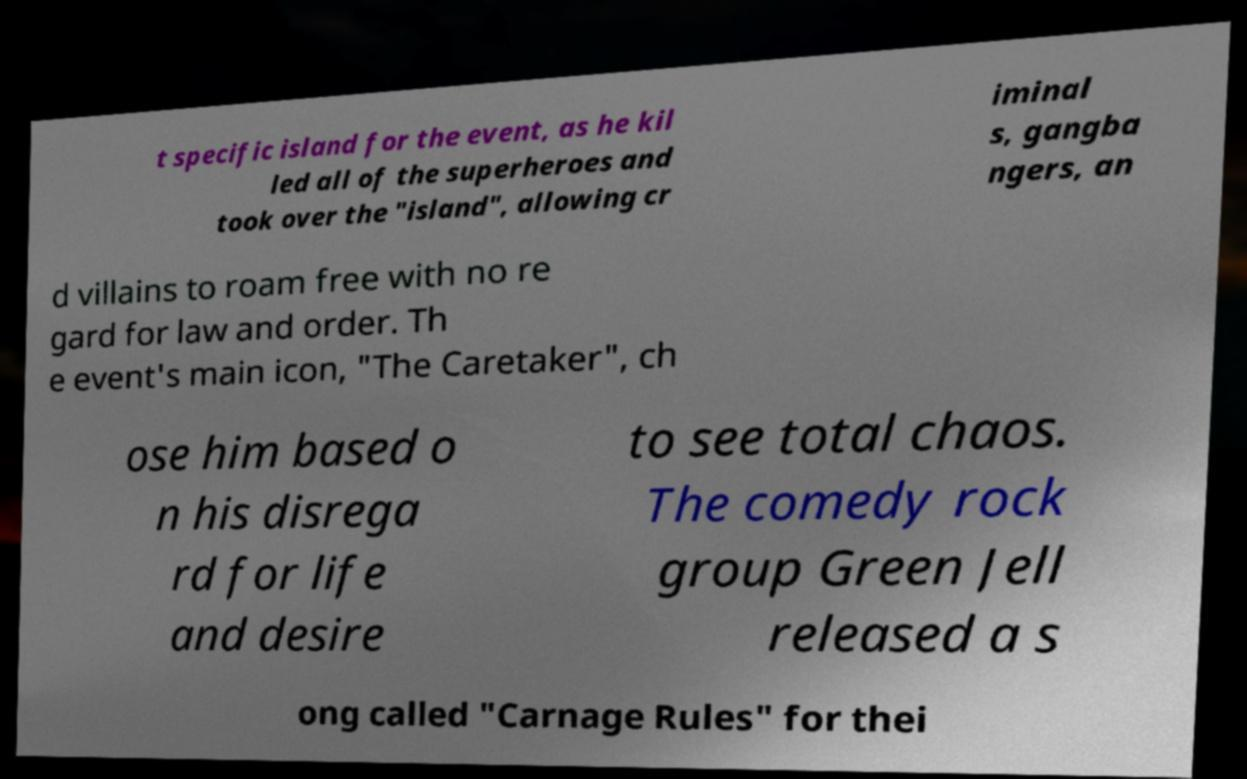Please identify and transcribe the text found in this image. t specific island for the event, as he kil led all of the superheroes and took over the "island", allowing cr iminal s, gangba ngers, an d villains to roam free with no re gard for law and order. Th e event's main icon, "The Caretaker", ch ose him based o n his disrega rd for life and desire to see total chaos. The comedy rock group Green Jell released a s ong called "Carnage Rules" for thei 